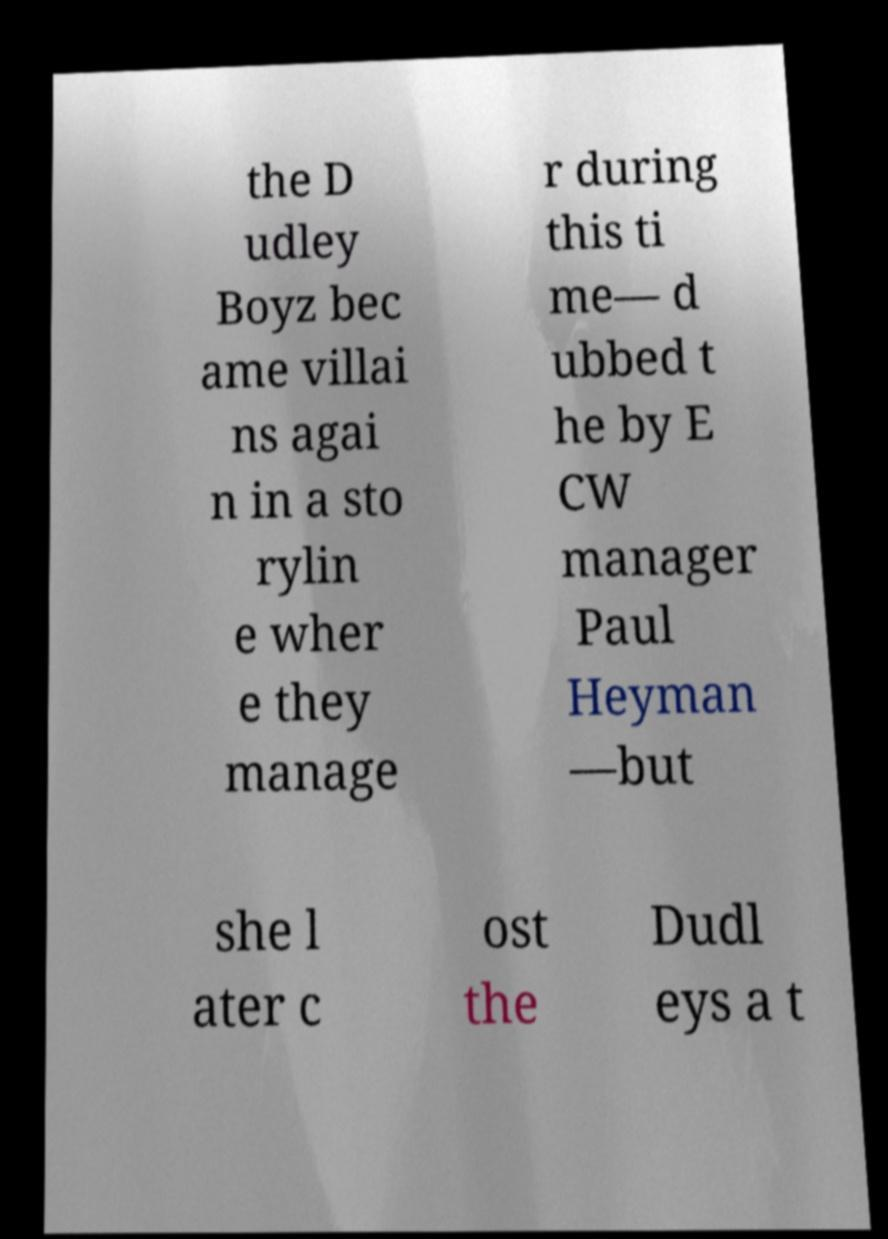Please read and relay the text visible in this image. What does it say? the D udley Boyz bec ame villai ns agai n in a sto rylin e wher e they manage r during this ti me— d ubbed t he by E CW manager Paul Heyman —but she l ater c ost the Dudl eys a t 